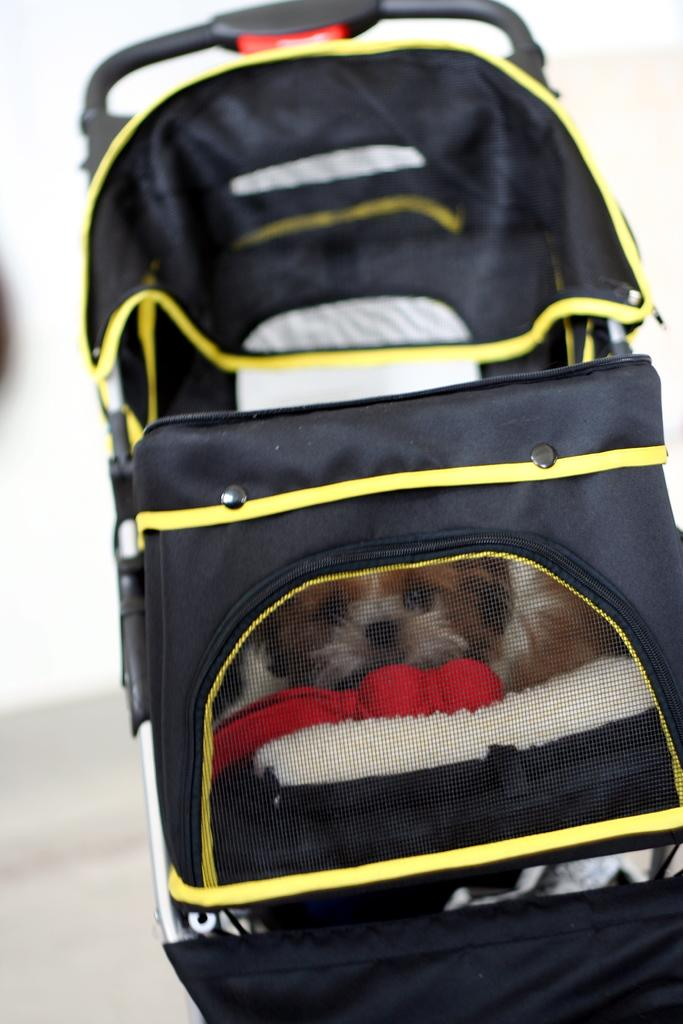What type of object is in the image? There is a baby trolley in the image. What colors are used for the baby trolley? The baby trolley is black and yellow in color. What feature is present in front of the baby trolley? There is a net in front of the baby trolley. What can be found inside the baby trolley? There is a dog inside the baby trolley. What type of question is being asked by the dog inside the baby trolley? There is no indication in the image that the dog is asking a question or capable of doing so. 